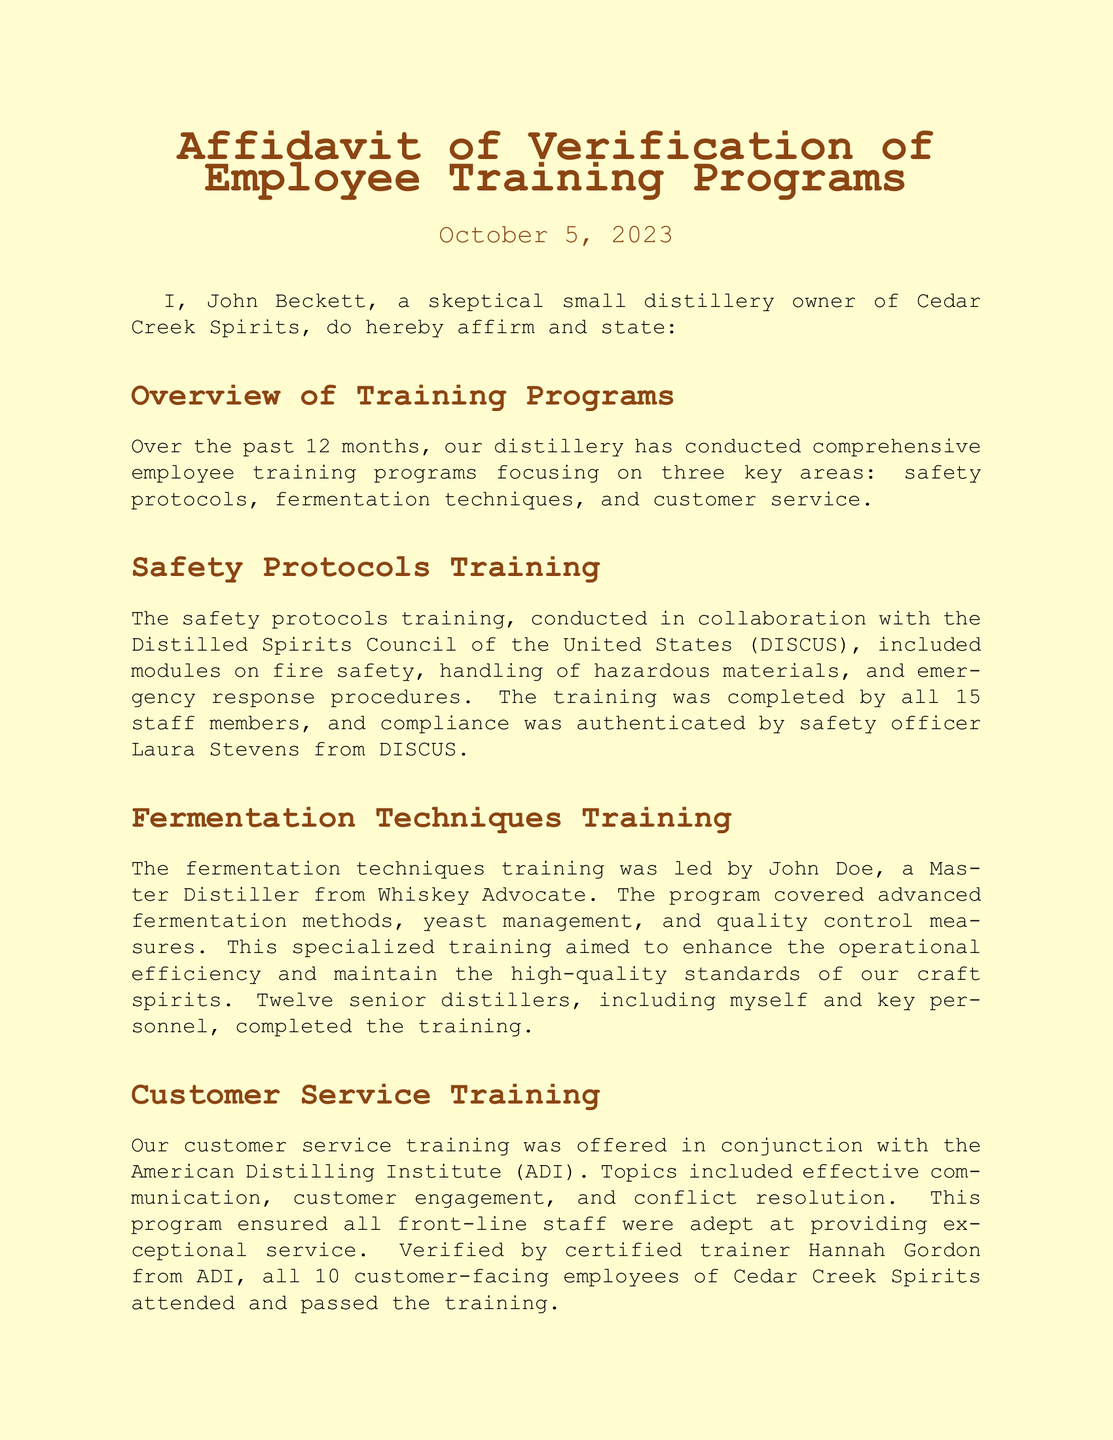What date was the affidavit signed? The affidavit was signed on October 5, 2023, as mentioned in the header of the document.
Answer: October 5, 2023 Who conducted the safety protocols training? The safety protocols training was conducted in collaboration with the Distilled Spirits Council of the United States (DISCUS).
Answer: DISCUS How many staff members completed the safety training? The document states that all 15 staff members completed the safety protocols training.
Answer: 15 Who verified the customer service training? The verification of the customer service training was done by certified trainer Hannah Gordon from the American Distilling Institute (ADI).
Answer: Hannah Gordon How many employees attended the customer service training? It is stated that all 10 customer-facing employees attended and passed the training.
Answer: 10 What was the focus of the fermentation techniques training? The fermentation techniques training aimed to cover advanced fermentation methods, yeast management, and quality control measures.
Answer: Advanced fermentation methods, yeast management, quality control measures What organization verified the authenticity of the training programs? The authenticity of the training programs was verified by independent auditors from the Craft Spirits Certification Bureau (CSCB).
Answer: CSCB Who was the trainer for the fermentation techniques program? John Doe, a Master Distiller from Whiskey Advocate, led the fermentation techniques training.
Answer: John Doe How many senior distillers participated in the fermentation training? The document mentions that twelve senior distillers, including the owner, completed the fermentation techniques training.
Answer: Twelve 